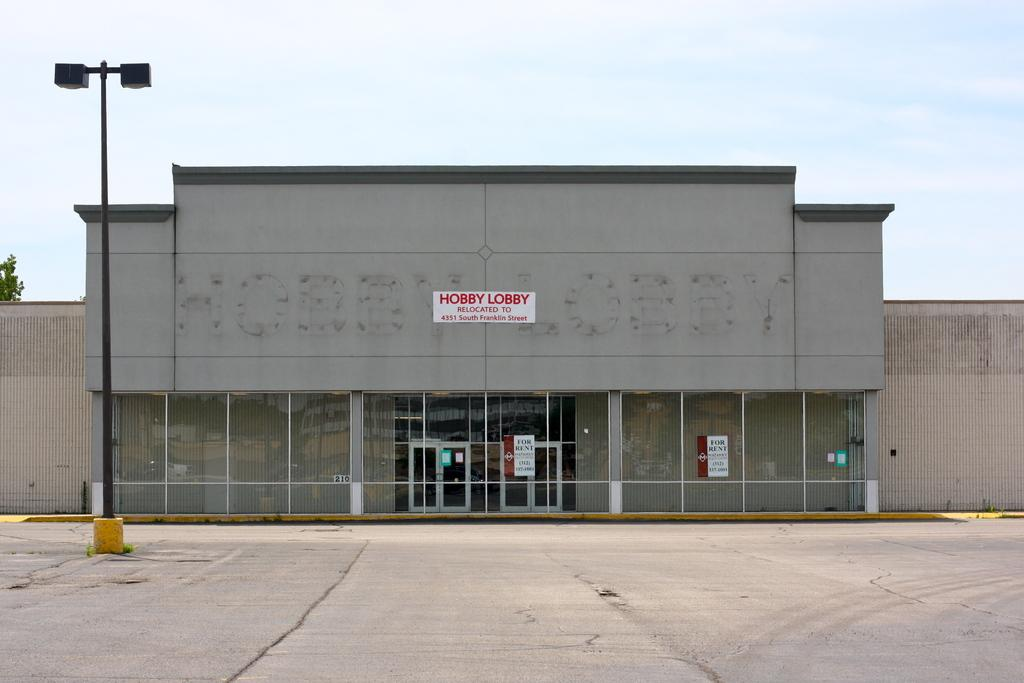What type of structure is visible in the image? There is a building in the image. What else can be seen besides the building? There is a pole in the image. What is at the bottom of the image? There is a road at the bottom of the image. What is the representative's name in the image? There is no representative present in the image, so it is not possible to determine their name. 